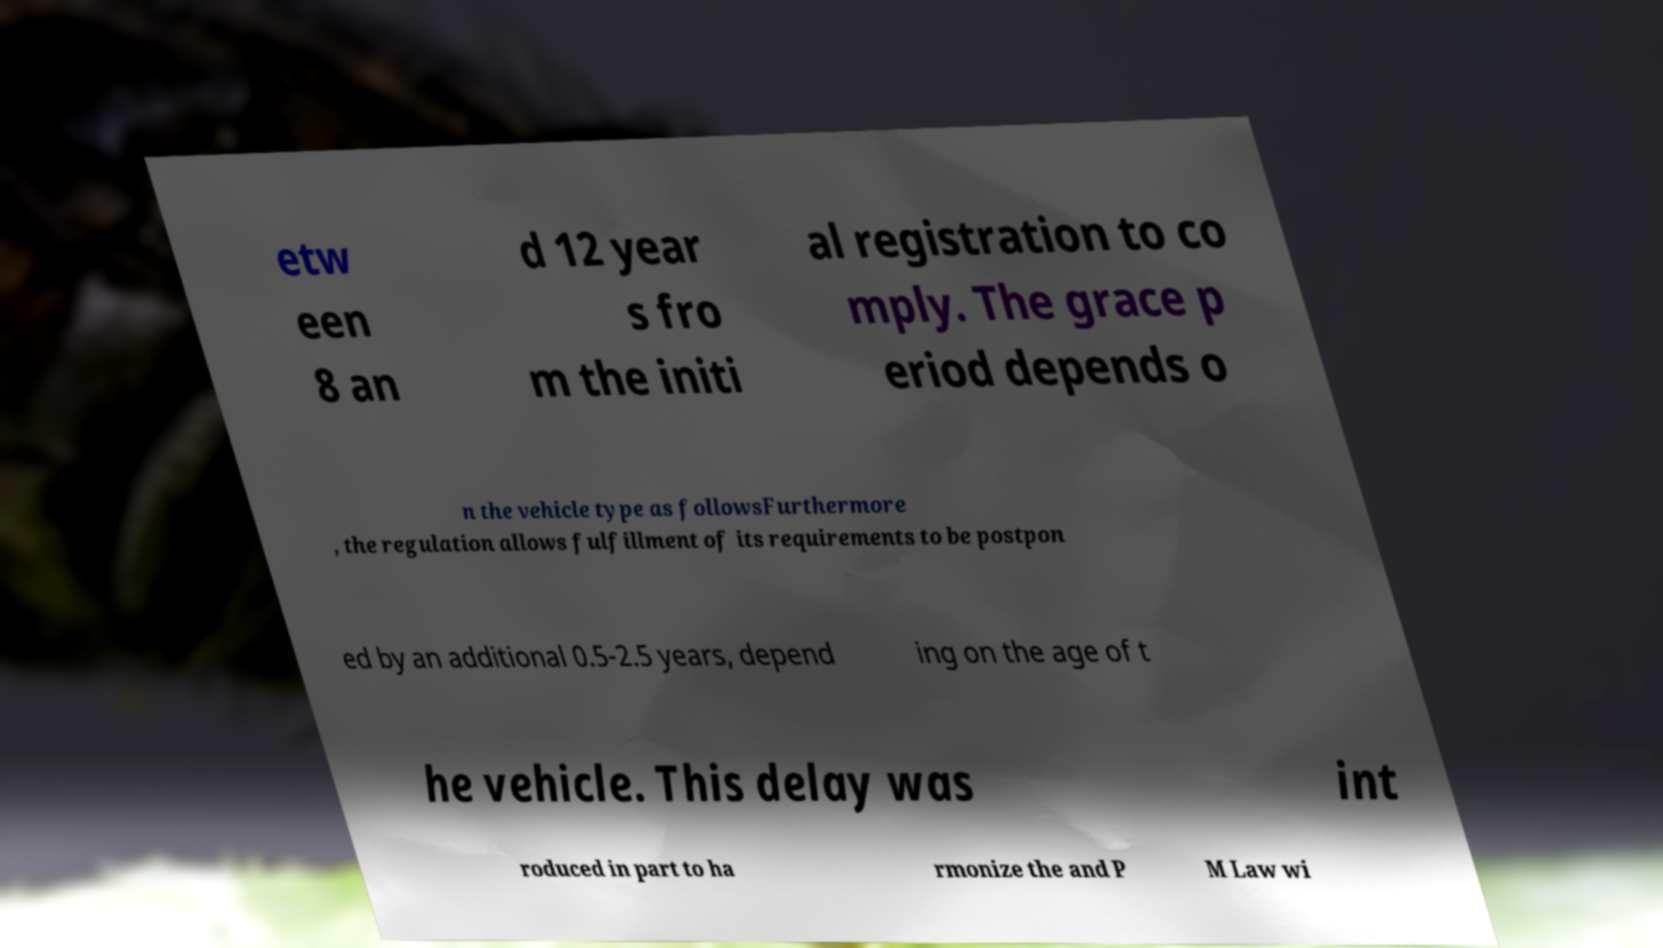Can you accurately transcribe the text from the provided image for me? etw een 8 an d 12 year s fro m the initi al registration to co mply. The grace p eriod depends o n the vehicle type as followsFurthermore , the regulation allows fulfillment of its requirements to be postpon ed by an additional 0.5-2.5 years, depend ing on the age of t he vehicle. This delay was int roduced in part to ha rmonize the and P M Law wi 